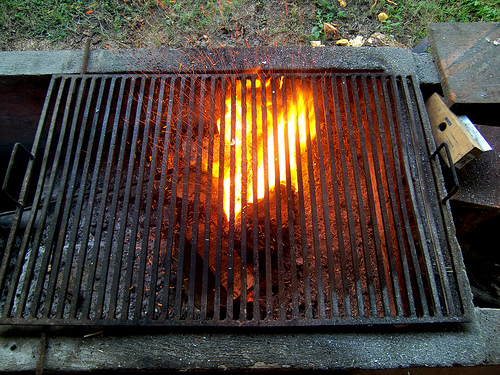<image>
Can you confirm if the fire is above the grill? No. The fire is not positioned above the grill. The vertical arrangement shows a different relationship. 